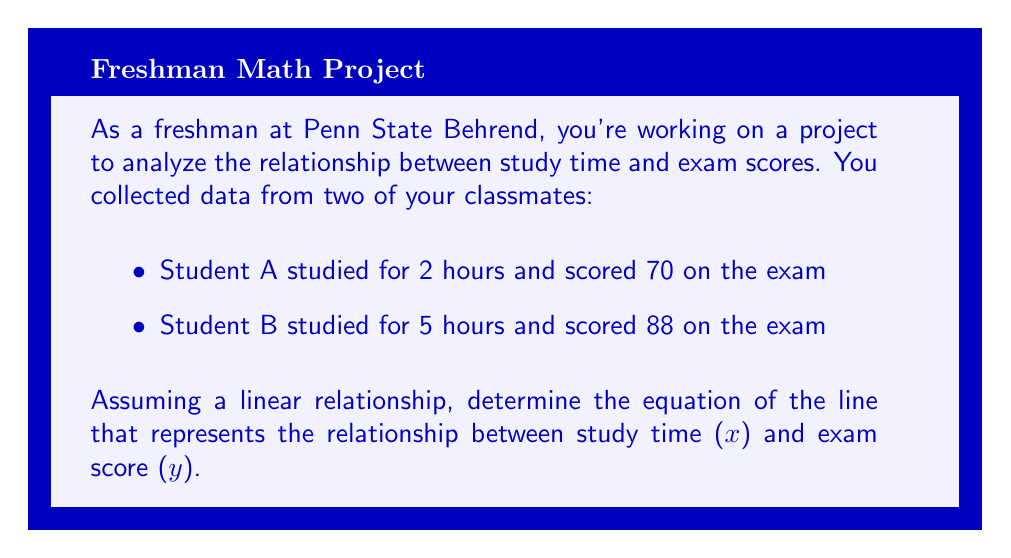Provide a solution to this math problem. To find the equation of a line given two points, we'll use the point-slope form of a line and then convert it to slope-intercept form. Let's follow these steps:

1. Identify the two points:
   Point 1 (x₁, y₁): (2, 70)
   Point 2 (x₂, y₂): (5, 88)

2. Calculate the slope (m) using the slope formula:
   $$m = \frac{y_2 - y_1}{x_2 - x_1} = \frac{88 - 70}{5 - 2} = \frac{18}{3} = 6$$

3. Use the point-slope form of a line with either point. Let's use (2, 70):
   $$(y - y_1) = m(x - x_1)$$
   $$(y - 70) = 6(x - 2)$$

4. Expand the equation:
   $$y - 70 = 6x - 12$$

5. Solve for y to get the slope-intercept form (y = mx + b):
   $$y = 6x - 12 + 70$$
   $$y = 6x + 58$$

Therefore, the equation of the line is $y = 6x + 58$, where x represents the number of study hours and y represents the exam score.
Answer: $y = 6x + 58$ 